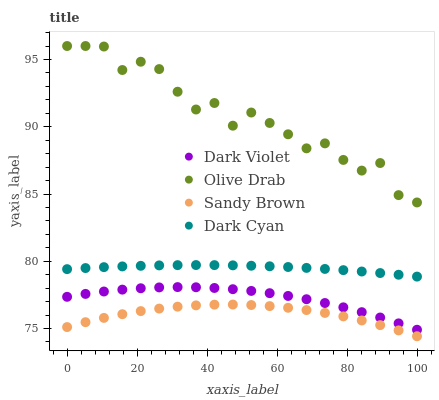Does Sandy Brown have the minimum area under the curve?
Answer yes or no. Yes. Does Olive Drab have the maximum area under the curve?
Answer yes or no. Yes. Does Olive Drab have the minimum area under the curve?
Answer yes or no. No. Does Sandy Brown have the maximum area under the curve?
Answer yes or no. No. Is Dark Cyan the smoothest?
Answer yes or no. Yes. Is Olive Drab the roughest?
Answer yes or no. Yes. Is Sandy Brown the smoothest?
Answer yes or no. No. Is Sandy Brown the roughest?
Answer yes or no. No. Does Sandy Brown have the lowest value?
Answer yes or no. Yes. Does Olive Drab have the lowest value?
Answer yes or no. No. Does Olive Drab have the highest value?
Answer yes or no. Yes. Does Sandy Brown have the highest value?
Answer yes or no. No. Is Dark Cyan less than Olive Drab?
Answer yes or no. Yes. Is Dark Cyan greater than Sandy Brown?
Answer yes or no. Yes. Does Dark Cyan intersect Olive Drab?
Answer yes or no. No. 